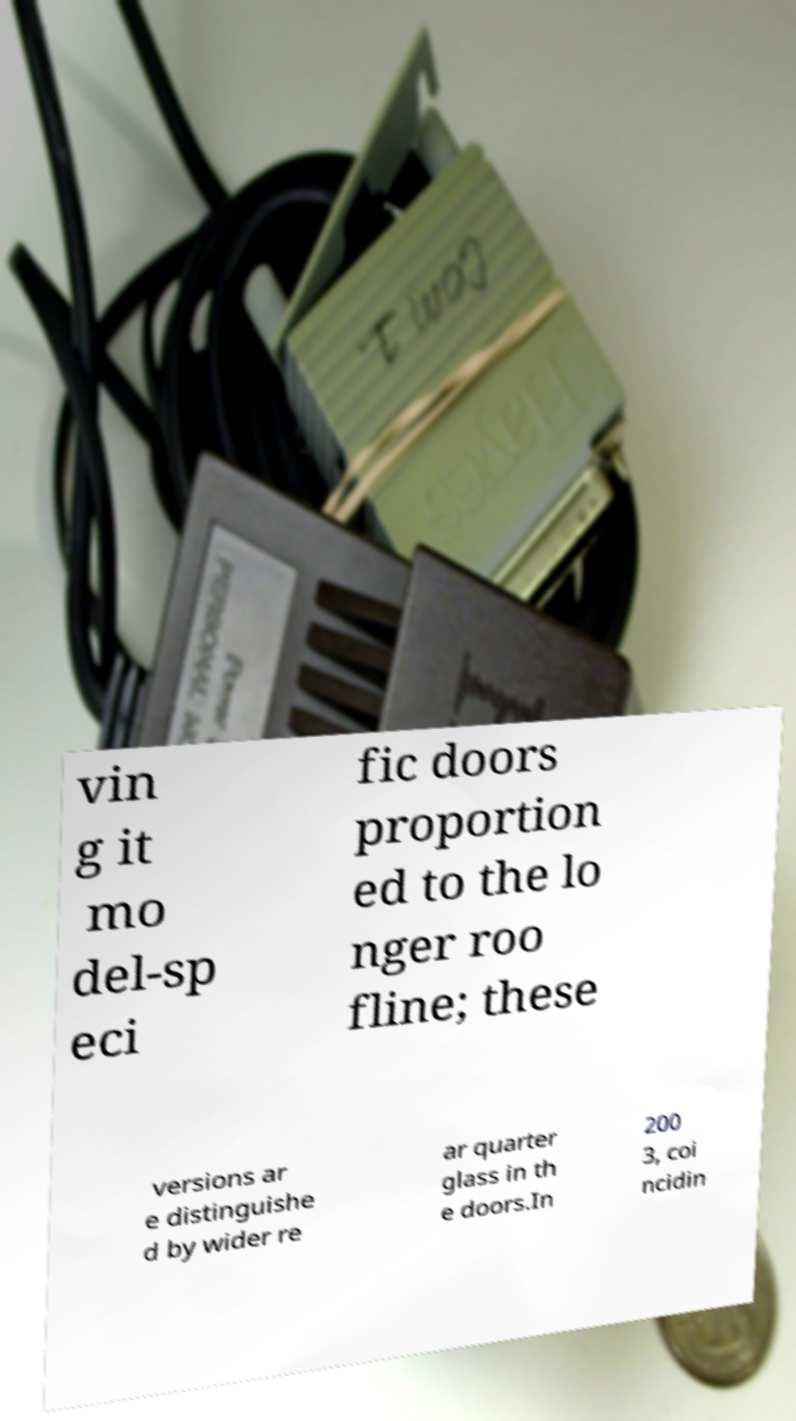Could you extract and type out the text from this image? vin g it mo del-sp eci fic doors proportion ed to the lo nger roo fline; these versions ar e distinguishe d by wider re ar quarter glass in th e doors.In 200 3, coi ncidin 